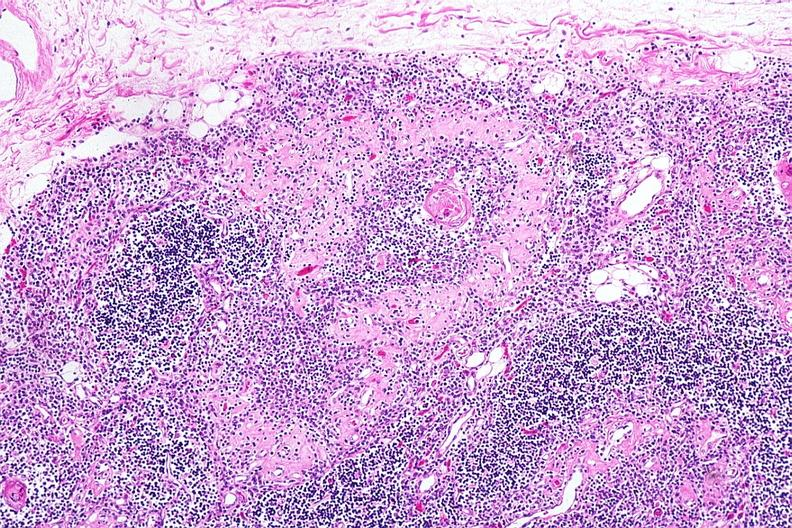s lymphangiomatosis present?
Answer the question using a single word or phrase. No 